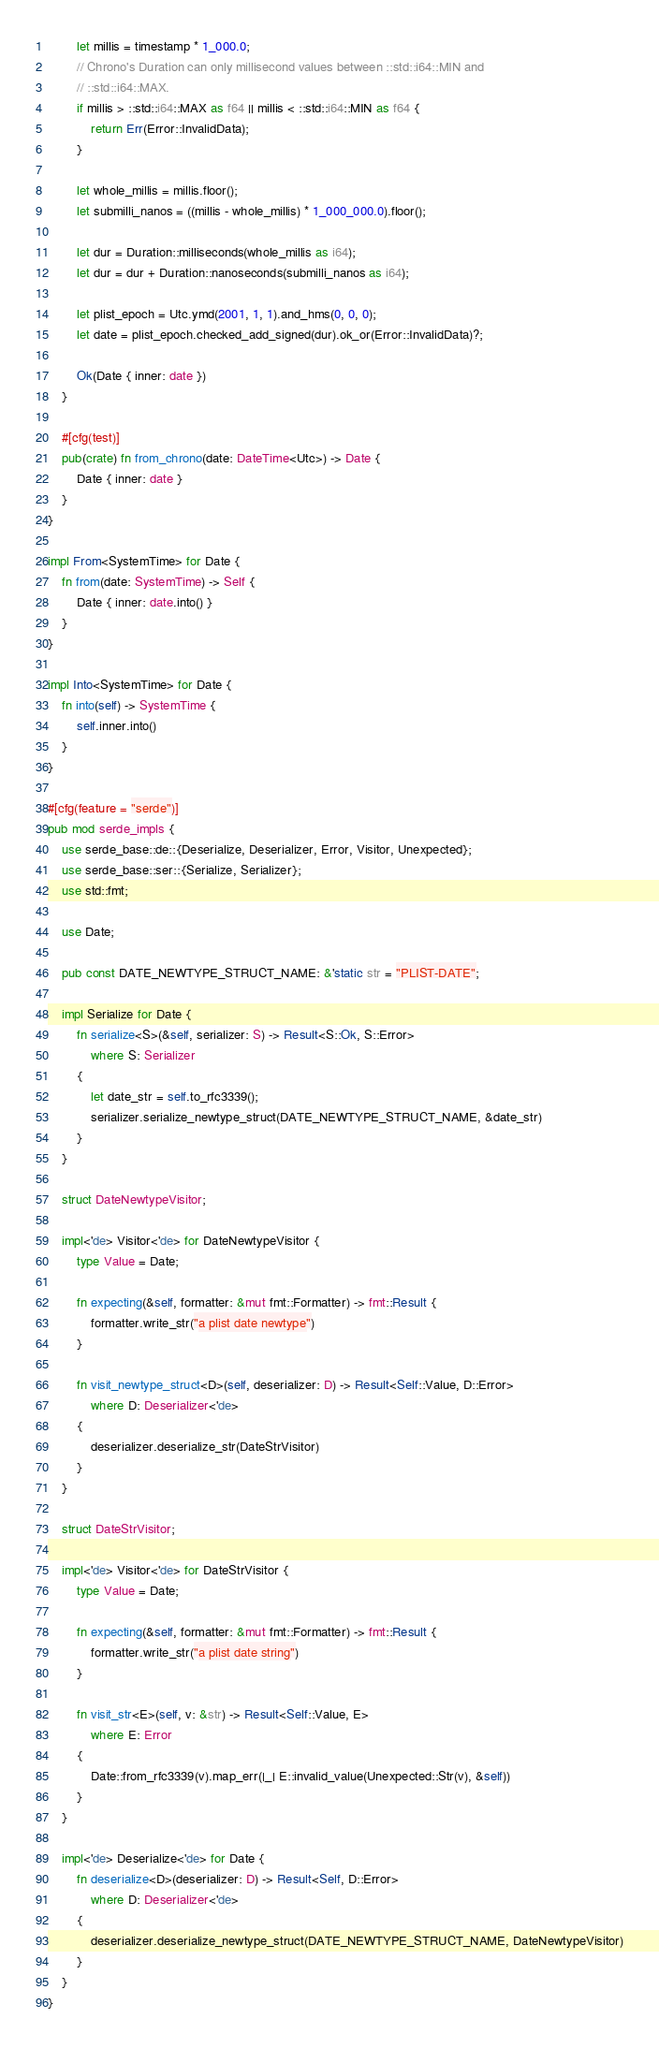Convert code to text. <code><loc_0><loc_0><loc_500><loc_500><_Rust_>
        let millis = timestamp * 1_000.0;
        // Chrono's Duration can only millisecond values between ::std::i64::MIN and
        // ::std::i64::MAX.
        if millis > ::std::i64::MAX as f64 || millis < ::std::i64::MIN as f64 {
            return Err(Error::InvalidData);
        }

        let whole_millis = millis.floor();
        let submilli_nanos = ((millis - whole_millis) * 1_000_000.0).floor();

        let dur = Duration::milliseconds(whole_millis as i64);
        let dur = dur + Duration::nanoseconds(submilli_nanos as i64);

        let plist_epoch = Utc.ymd(2001, 1, 1).and_hms(0, 0, 0);
        let date = plist_epoch.checked_add_signed(dur).ok_or(Error::InvalidData)?;

        Ok(Date { inner: date })
    }

    #[cfg(test)]
    pub(crate) fn from_chrono(date: DateTime<Utc>) -> Date {
        Date { inner: date }
    }
}

impl From<SystemTime> for Date {
    fn from(date: SystemTime) -> Self {
        Date { inner: date.into() }
    }
}

impl Into<SystemTime> for Date {
    fn into(self) -> SystemTime {
        self.inner.into()
    }
}

#[cfg(feature = "serde")]
pub mod serde_impls {
    use serde_base::de::{Deserialize, Deserializer, Error, Visitor, Unexpected};
    use serde_base::ser::{Serialize, Serializer};
    use std::fmt;

    use Date;

    pub const DATE_NEWTYPE_STRUCT_NAME: &'static str = "PLIST-DATE";

    impl Serialize for Date {
        fn serialize<S>(&self, serializer: S) -> Result<S::Ok, S::Error>
            where S: Serializer
        {
            let date_str = self.to_rfc3339();
            serializer.serialize_newtype_struct(DATE_NEWTYPE_STRUCT_NAME, &date_str)
        }
    }

    struct DateNewtypeVisitor;

    impl<'de> Visitor<'de> for DateNewtypeVisitor {
        type Value = Date;

        fn expecting(&self, formatter: &mut fmt::Formatter) -> fmt::Result {
            formatter.write_str("a plist date newtype")
        }

        fn visit_newtype_struct<D>(self, deserializer: D) -> Result<Self::Value, D::Error>
            where D: Deserializer<'de>
        {
            deserializer.deserialize_str(DateStrVisitor)
        }
    }

    struct DateStrVisitor;

    impl<'de> Visitor<'de> for DateStrVisitor {
        type Value = Date;

        fn expecting(&self, formatter: &mut fmt::Formatter) -> fmt::Result {
            formatter.write_str("a plist date string")
        }

        fn visit_str<E>(self, v: &str) -> Result<Self::Value, E>
            where E: Error
        {
            Date::from_rfc3339(v).map_err(|_| E::invalid_value(Unexpected::Str(v), &self))
        }
    }

    impl<'de> Deserialize<'de> for Date {
        fn deserialize<D>(deserializer: D) -> Result<Self, D::Error>
            where D: Deserializer<'de>
        {
            deserializer.deserialize_newtype_struct(DATE_NEWTYPE_STRUCT_NAME, DateNewtypeVisitor)
        }
    }
}
</code> 